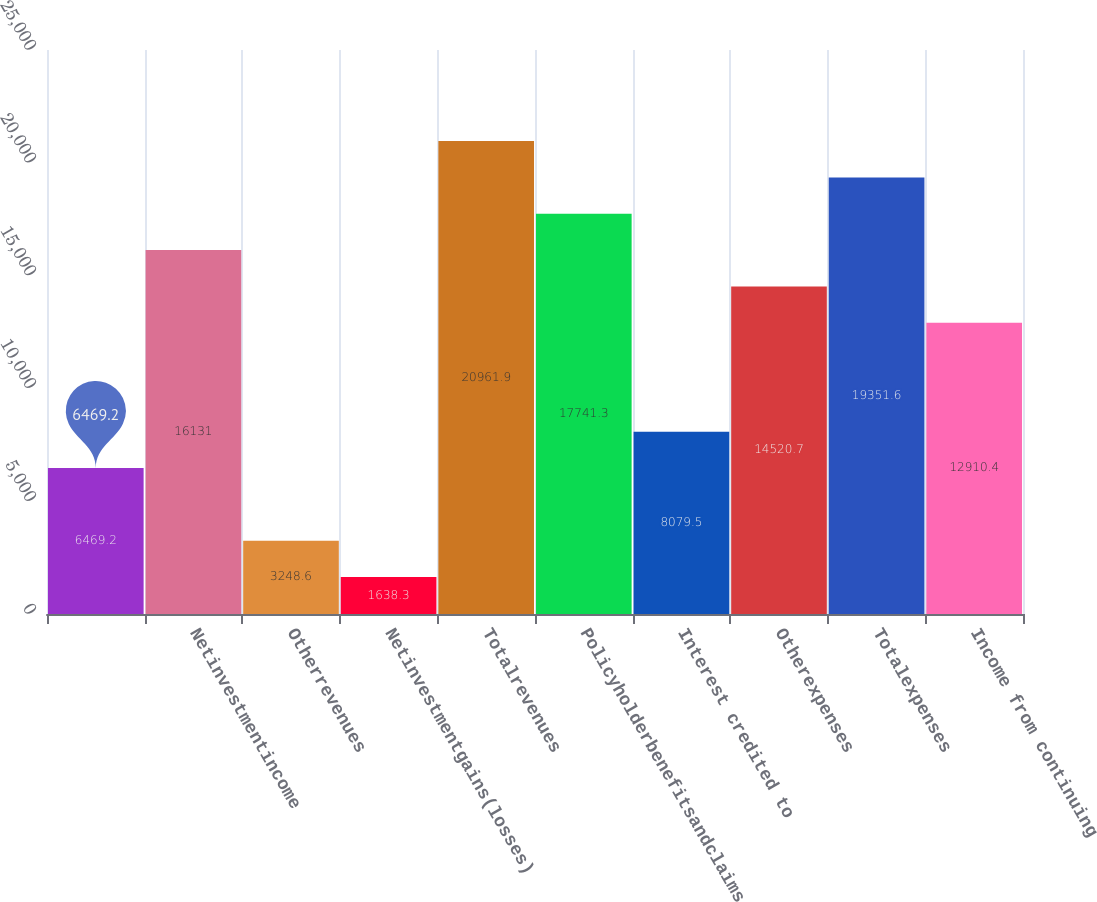<chart> <loc_0><loc_0><loc_500><loc_500><bar_chart><ecel><fcel>Netinvestmentincome<fcel>Otherrevenues<fcel>Netinvestmentgains(losses)<fcel>Totalrevenues<fcel>Policyholderbenefitsandclaims<fcel>Interest credited to<fcel>Otherexpenses<fcel>Totalexpenses<fcel>Income from continuing<nl><fcel>6469.2<fcel>16131<fcel>3248.6<fcel>1638.3<fcel>20961.9<fcel>17741.3<fcel>8079.5<fcel>14520.7<fcel>19351.6<fcel>12910.4<nl></chart> 